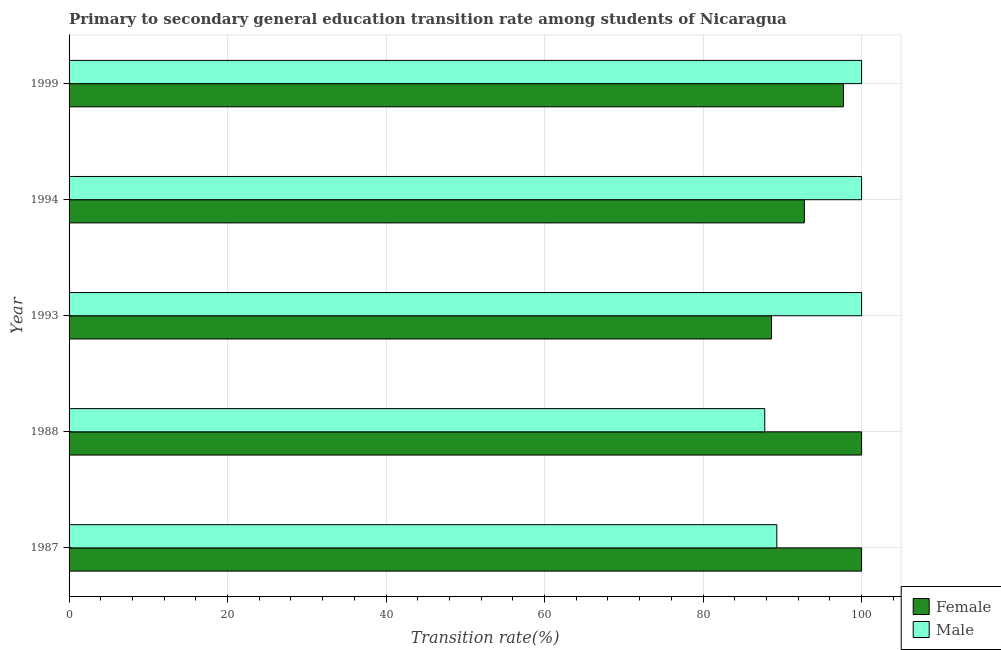How many different coloured bars are there?
Ensure brevity in your answer.  2. How many groups of bars are there?
Ensure brevity in your answer.  5. What is the transition rate among female students in 1993?
Offer a terse response. 88.63. Across all years, what is the minimum transition rate among male students?
Provide a short and direct response. 87.78. In which year was the transition rate among female students maximum?
Keep it short and to the point. 1987. What is the total transition rate among female students in the graph?
Offer a terse response. 479.12. What is the difference between the transition rate among female students in 1987 and that in 1994?
Offer a terse response. 7.22. What is the difference between the transition rate among female students in 1988 and the transition rate among male students in 1993?
Make the answer very short. 0. What is the average transition rate among male students per year?
Keep it short and to the point. 95.42. In the year 1999, what is the difference between the transition rate among male students and transition rate among female students?
Ensure brevity in your answer.  2.29. In how many years, is the transition rate among male students greater than 32 %?
Offer a very short reply. 5. What is the ratio of the transition rate among female students in 1987 to that in 1994?
Provide a succinct answer. 1.08. Is the transition rate among female students in 1987 less than that in 1988?
Your response must be concise. No. Is the difference between the transition rate among male students in 1987 and 1993 greater than the difference between the transition rate among female students in 1987 and 1993?
Your answer should be compact. No. What is the difference between the highest and the second highest transition rate among male students?
Your answer should be compact. 0. What is the difference between the highest and the lowest transition rate among male students?
Keep it short and to the point. 12.22. Is the sum of the transition rate among female students in 1988 and 1994 greater than the maximum transition rate among male students across all years?
Make the answer very short. Yes. How many bars are there?
Offer a terse response. 10. Are all the bars in the graph horizontal?
Your answer should be very brief. Yes. What is the difference between two consecutive major ticks on the X-axis?
Ensure brevity in your answer.  20. Are the values on the major ticks of X-axis written in scientific E-notation?
Keep it short and to the point. No. Does the graph contain any zero values?
Provide a short and direct response. No. Does the graph contain grids?
Keep it short and to the point. Yes. What is the title of the graph?
Give a very brief answer. Primary to secondary general education transition rate among students of Nicaragua. Does "Overweight" appear as one of the legend labels in the graph?
Provide a succinct answer. No. What is the label or title of the X-axis?
Your answer should be very brief. Transition rate(%). What is the label or title of the Y-axis?
Provide a short and direct response. Year. What is the Transition rate(%) in Male in 1987?
Offer a very short reply. 89.31. What is the Transition rate(%) in Female in 1988?
Your answer should be very brief. 100. What is the Transition rate(%) in Male in 1988?
Provide a short and direct response. 87.78. What is the Transition rate(%) of Female in 1993?
Ensure brevity in your answer.  88.63. What is the Transition rate(%) in Female in 1994?
Ensure brevity in your answer.  92.78. What is the Transition rate(%) in Female in 1999?
Give a very brief answer. 97.71. What is the Transition rate(%) in Male in 1999?
Give a very brief answer. 100. Across all years, what is the minimum Transition rate(%) of Female?
Offer a very short reply. 88.63. Across all years, what is the minimum Transition rate(%) in Male?
Offer a very short reply. 87.78. What is the total Transition rate(%) of Female in the graph?
Your response must be concise. 479.12. What is the total Transition rate(%) of Male in the graph?
Ensure brevity in your answer.  477.09. What is the difference between the Transition rate(%) in Male in 1987 and that in 1988?
Keep it short and to the point. 1.52. What is the difference between the Transition rate(%) in Female in 1987 and that in 1993?
Provide a succinct answer. 11.37. What is the difference between the Transition rate(%) of Male in 1987 and that in 1993?
Provide a succinct answer. -10.69. What is the difference between the Transition rate(%) in Female in 1987 and that in 1994?
Offer a terse response. 7.22. What is the difference between the Transition rate(%) of Male in 1987 and that in 1994?
Your answer should be very brief. -10.69. What is the difference between the Transition rate(%) of Female in 1987 and that in 1999?
Provide a short and direct response. 2.29. What is the difference between the Transition rate(%) of Male in 1987 and that in 1999?
Provide a short and direct response. -10.69. What is the difference between the Transition rate(%) in Female in 1988 and that in 1993?
Your answer should be very brief. 11.37. What is the difference between the Transition rate(%) in Male in 1988 and that in 1993?
Provide a short and direct response. -12.22. What is the difference between the Transition rate(%) of Female in 1988 and that in 1994?
Your answer should be very brief. 7.22. What is the difference between the Transition rate(%) of Male in 1988 and that in 1994?
Make the answer very short. -12.22. What is the difference between the Transition rate(%) of Female in 1988 and that in 1999?
Give a very brief answer. 2.29. What is the difference between the Transition rate(%) of Male in 1988 and that in 1999?
Your answer should be compact. -12.22. What is the difference between the Transition rate(%) in Female in 1993 and that in 1994?
Offer a terse response. -4.15. What is the difference between the Transition rate(%) of Male in 1993 and that in 1994?
Make the answer very short. 0. What is the difference between the Transition rate(%) of Female in 1993 and that in 1999?
Make the answer very short. -9.08. What is the difference between the Transition rate(%) of Male in 1993 and that in 1999?
Make the answer very short. 0. What is the difference between the Transition rate(%) in Female in 1994 and that in 1999?
Your answer should be very brief. -4.93. What is the difference between the Transition rate(%) of Male in 1994 and that in 1999?
Ensure brevity in your answer.  0. What is the difference between the Transition rate(%) of Female in 1987 and the Transition rate(%) of Male in 1988?
Provide a short and direct response. 12.22. What is the difference between the Transition rate(%) of Female in 1987 and the Transition rate(%) of Male in 1993?
Provide a succinct answer. 0. What is the difference between the Transition rate(%) of Female in 1987 and the Transition rate(%) of Male in 1994?
Make the answer very short. 0. What is the difference between the Transition rate(%) in Female in 1988 and the Transition rate(%) in Male in 1993?
Provide a succinct answer. 0. What is the difference between the Transition rate(%) in Female in 1993 and the Transition rate(%) in Male in 1994?
Your answer should be very brief. -11.37. What is the difference between the Transition rate(%) in Female in 1993 and the Transition rate(%) in Male in 1999?
Offer a very short reply. -11.37. What is the difference between the Transition rate(%) of Female in 1994 and the Transition rate(%) of Male in 1999?
Provide a short and direct response. -7.22. What is the average Transition rate(%) in Female per year?
Provide a short and direct response. 95.83. What is the average Transition rate(%) of Male per year?
Keep it short and to the point. 95.42. In the year 1987, what is the difference between the Transition rate(%) in Female and Transition rate(%) in Male?
Provide a succinct answer. 10.69. In the year 1988, what is the difference between the Transition rate(%) of Female and Transition rate(%) of Male?
Your answer should be compact. 12.22. In the year 1993, what is the difference between the Transition rate(%) of Female and Transition rate(%) of Male?
Make the answer very short. -11.37. In the year 1994, what is the difference between the Transition rate(%) in Female and Transition rate(%) in Male?
Offer a terse response. -7.22. In the year 1999, what is the difference between the Transition rate(%) in Female and Transition rate(%) in Male?
Your response must be concise. -2.29. What is the ratio of the Transition rate(%) in Male in 1987 to that in 1988?
Your answer should be compact. 1.02. What is the ratio of the Transition rate(%) of Female in 1987 to that in 1993?
Your response must be concise. 1.13. What is the ratio of the Transition rate(%) of Male in 1987 to that in 1993?
Offer a terse response. 0.89. What is the ratio of the Transition rate(%) of Female in 1987 to that in 1994?
Offer a very short reply. 1.08. What is the ratio of the Transition rate(%) of Male in 1987 to that in 1994?
Keep it short and to the point. 0.89. What is the ratio of the Transition rate(%) in Female in 1987 to that in 1999?
Your answer should be very brief. 1.02. What is the ratio of the Transition rate(%) in Male in 1987 to that in 1999?
Ensure brevity in your answer.  0.89. What is the ratio of the Transition rate(%) of Female in 1988 to that in 1993?
Your response must be concise. 1.13. What is the ratio of the Transition rate(%) in Male in 1988 to that in 1993?
Keep it short and to the point. 0.88. What is the ratio of the Transition rate(%) of Female in 1988 to that in 1994?
Your response must be concise. 1.08. What is the ratio of the Transition rate(%) of Male in 1988 to that in 1994?
Make the answer very short. 0.88. What is the ratio of the Transition rate(%) in Female in 1988 to that in 1999?
Offer a terse response. 1.02. What is the ratio of the Transition rate(%) in Male in 1988 to that in 1999?
Keep it short and to the point. 0.88. What is the ratio of the Transition rate(%) of Female in 1993 to that in 1994?
Provide a succinct answer. 0.96. What is the ratio of the Transition rate(%) in Male in 1993 to that in 1994?
Your response must be concise. 1. What is the ratio of the Transition rate(%) in Female in 1993 to that in 1999?
Give a very brief answer. 0.91. What is the ratio of the Transition rate(%) in Male in 1993 to that in 1999?
Your answer should be compact. 1. What is the ratio of the Transition rate(%) of Female in 1994 to that in 1999?
Give a very brief answer. 0.95. What is the ratio of the Transition rate(%) of Male in 1994 to that in 1999?
Offer a very short reply. 1. What is the difference between the highest and the second highest Transition rate(%) of Male?
Offer a terse response. 0. What is the difference between the highest and the lowest Transition rate(%) in Female?
Provide a short and direct response. 11.37. What is the difference between the highest and the lowest Transition rate(%) in Male?
Offer a very short reply. 12.22. 